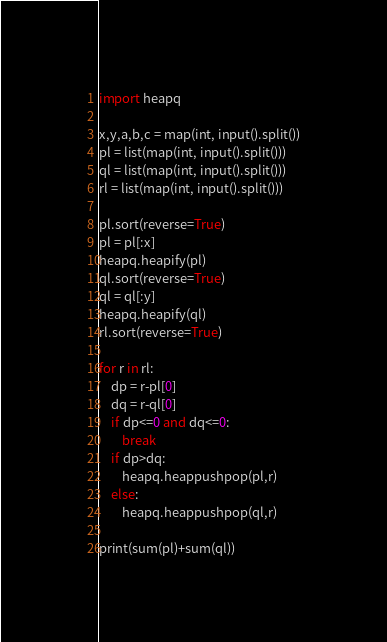<code> <loc_0><loc_0><loc_500><loc_500><_Python_>import heapq

x,y,a,b,c = map(int, input().split())
pl = list(map(int, input().split()))
ql = list(map(int, input().split()))
rl = list(map(int, input().split()))

pl.sort(reverse=True)
pl = pl[:x]
heapq.heapify(pl)
ql.sort(reverse=True)
ql = ql[:y]
heapq.heapify(ql)
rl.sort(reverse=True)

for r in rl:
    dp = r-pl[0]
    dq = r-ql[0]
    if dp<=0 and dq<=0:
        break
    if dp>dq:
        heapq.heappushpop(pl,r)
    else:
        heapq.heappushpop(ql,r)

print(sum(pl)+sum(ql))</code> 